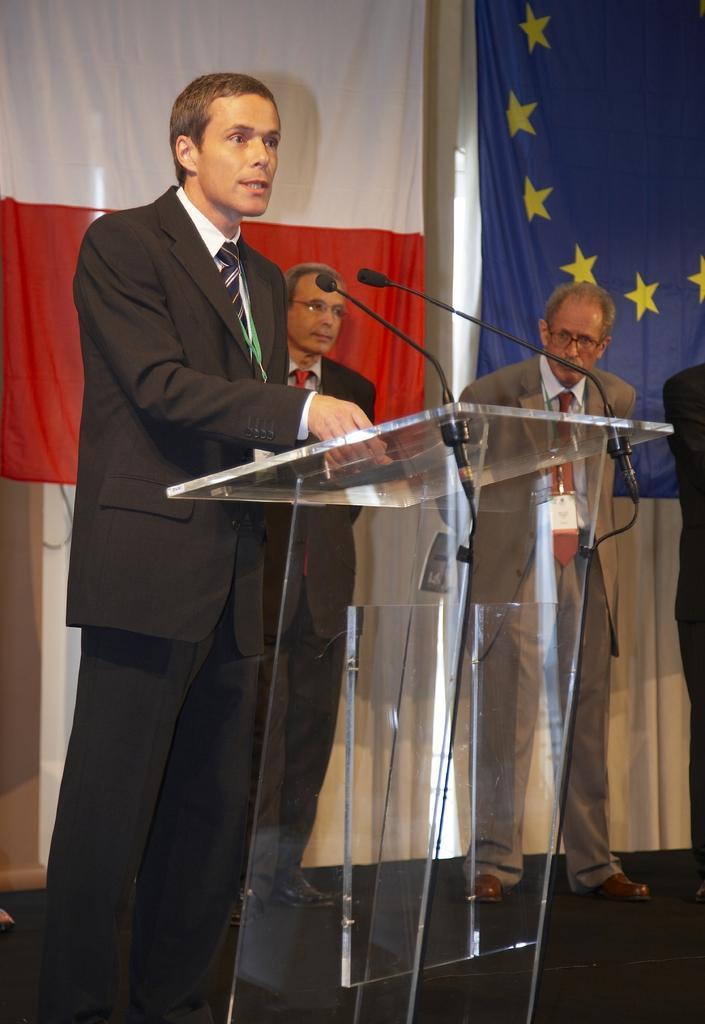Please provide a concise description of this image. There is a man standing in front of a mic and a desk in the foreground area of the image, there are people and flags in the background. 